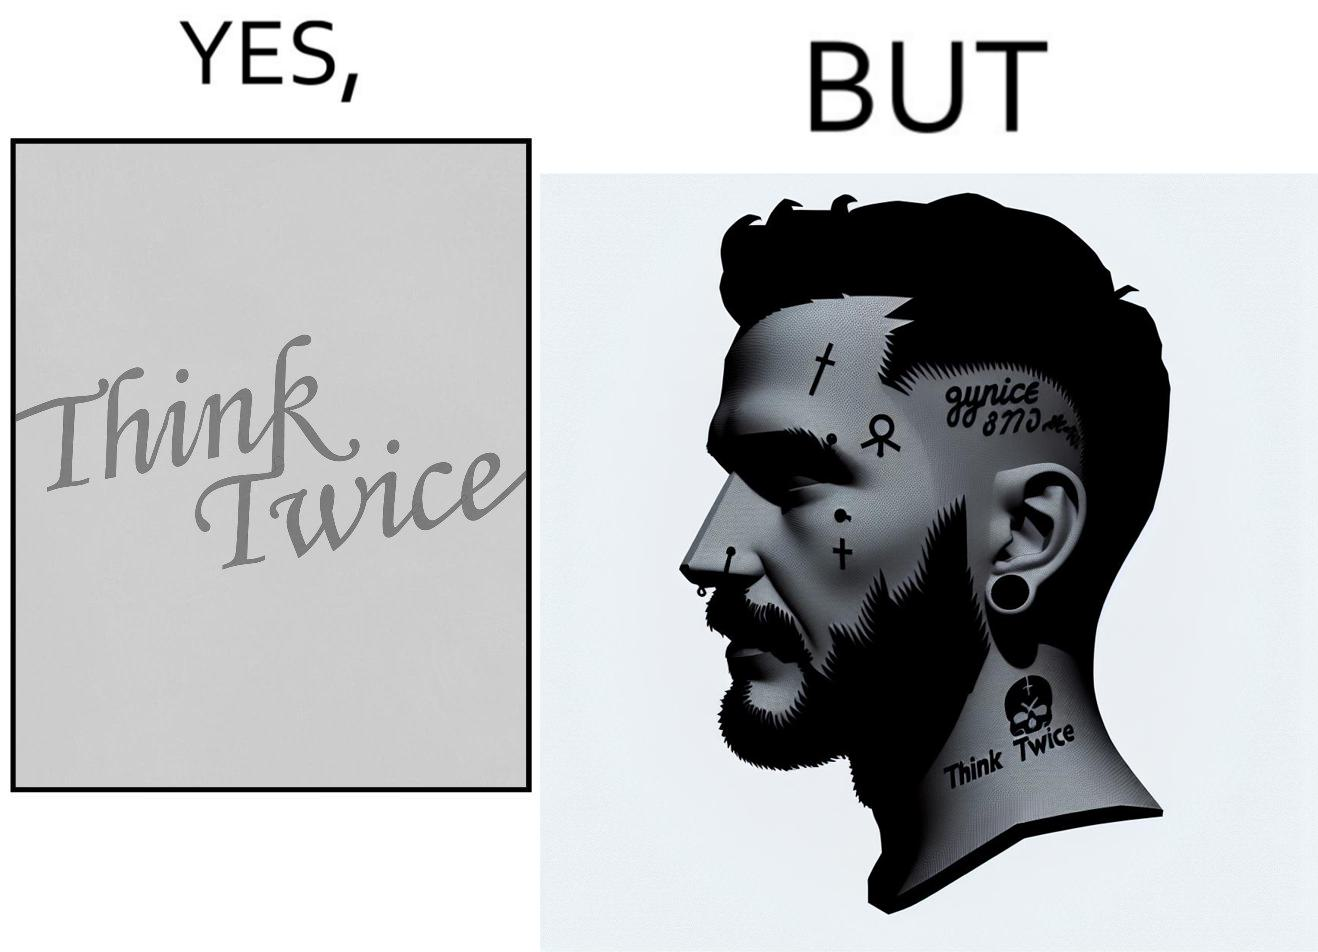Is this a satirical image? Yes, this image is satirical. 